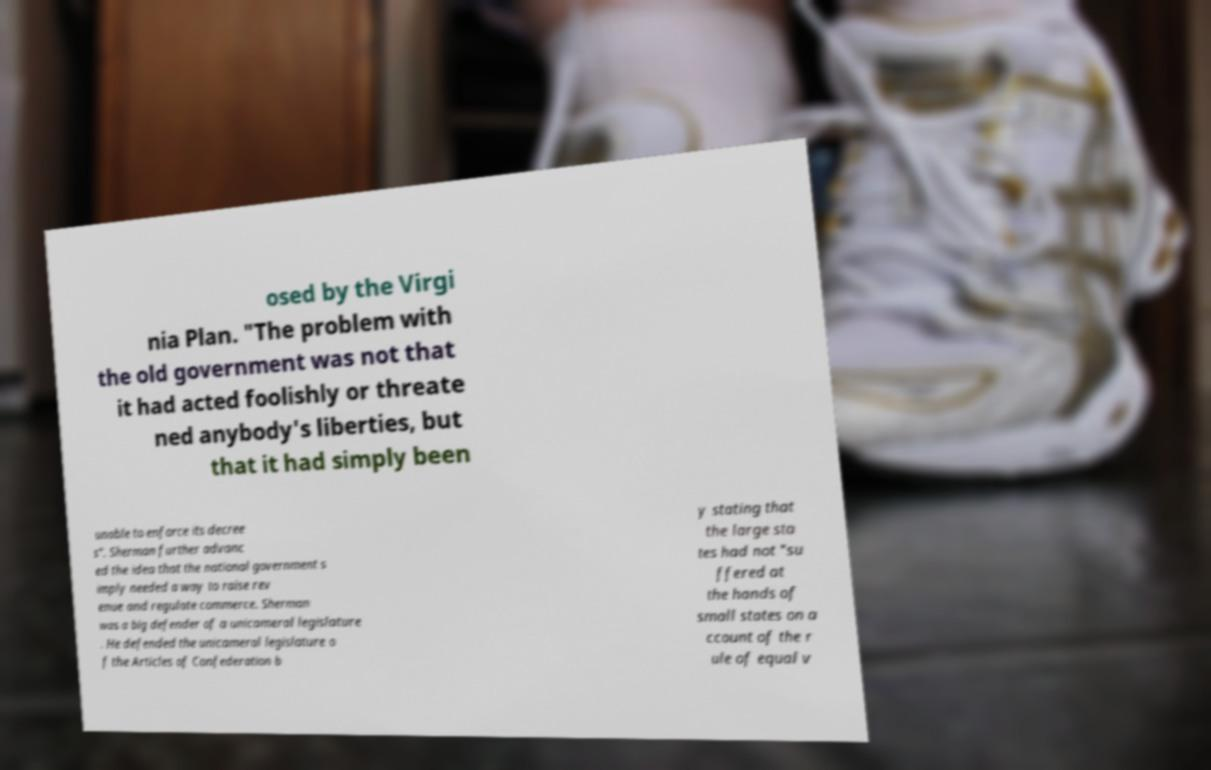Can you accurately transcribe the text from the provided image for me? osed by the Virgi nia Plan. "The problem with the old government was not that it had acted foolishly or threate ned anybody's liberties, but that it had simply been unable to enforce its decree s". Sherman further advanc ed the idea that the national government s imply needed a way to raise rev enue and regulate commerce. Sherman was a big defender of a unicameral legislature . He defended the unicameral legislature o f the Articles of Confederation b y stating that the large sta tes had not "su ffered at the hands of small states on a ccount of the r ule of equal v 